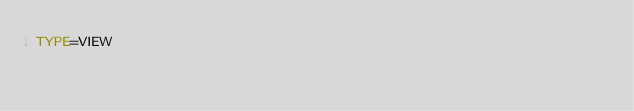Convert code to text. <code><loc_0><loc_0><loc_500><loc_500><_VisualBasic_>TYPE=VIEW</code> 